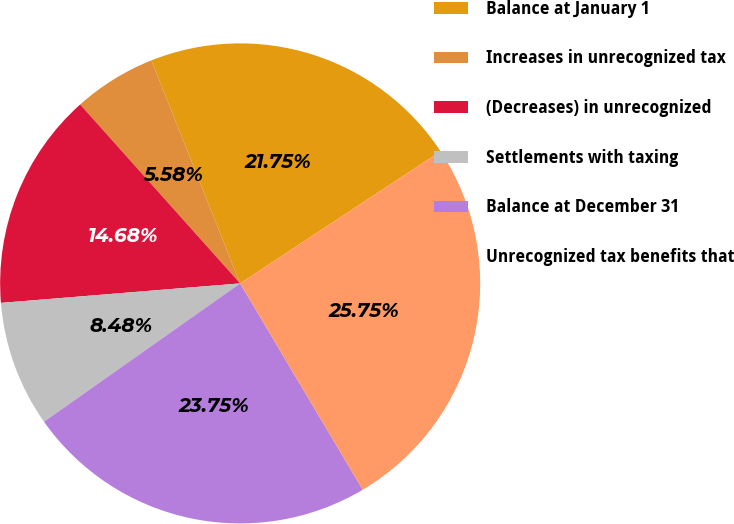<chart> <loc_0><loc_0><loc_500><loc_500><pie_chart><fcel>Balance at January 1<fcel>Increases in unrecognized tax<fcel>(Decreases) in unrecognized<fcel>Settlements with taxing<fcel>Balance at December 31<fcel>Unrecognized tax benefits that<nl><fcel>21.75%<fcel>5.58%<fcel>14.68%<fcel>8.48%<fcel>23.75%<fcel>25.74%<nl></chart> 